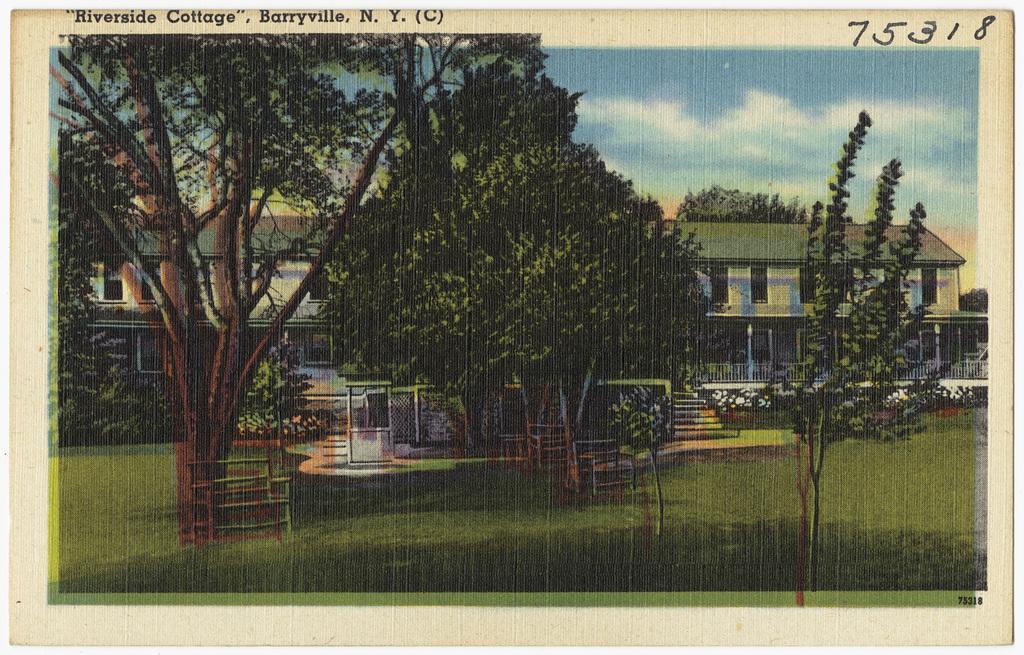Describe this image in one or two sentences. In this image there is a picture. In the picture there are buildings. In front of the buildings there are trees and benches on the ground. There is grass on the ground. At the top there is the sky. At the top of the image there is text above the picture. 